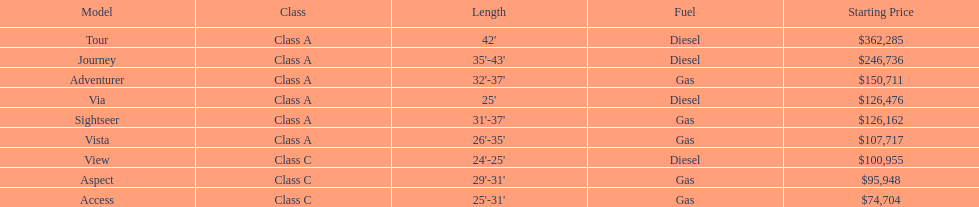Which model had the highest starting price Tour. 